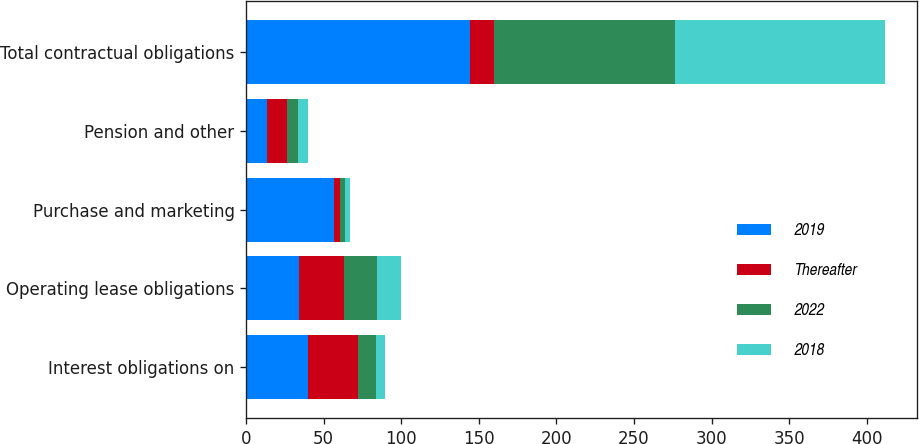Convert chart to OTSL. <chart><loc_0><loc_0><loc_500><loc_500><stacked_bar_chart><ecel><fcel>Interest obligations on<fcel>Operating lease obligations<fcel>Purchase and marketing<fcel>Pension and other<fcel>Total contractual obligations<nl><fcel>2019<fcel>39.8<fcel>34<fcel>56.8<fcel>13.7<fcel>144.3<nl><fcel>Thereafter<fcel>32.4<fcel>29.1<fcel>3.9<fcel>12.8<fcel>15.6<nl><fcel>2022<fcel>11.4<fcel>21.2<fcel>3.1<fcel>6.7<fcel>116.4<nl><fcel>2018<fcel>6.2<fcel>15.6<fcel>3.2<fcel>6.7<fcel>135.5<nl></chart> 